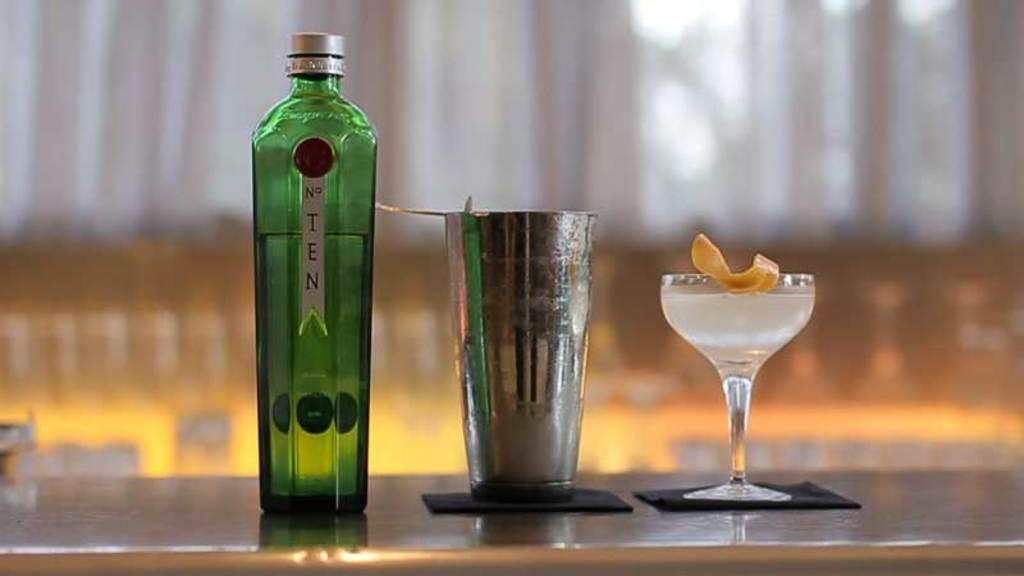<image>
Render a clear and concise summary of the photo. A bottle of No. 10 gin sits on a counter next to a shaker and a filled martini glass. 